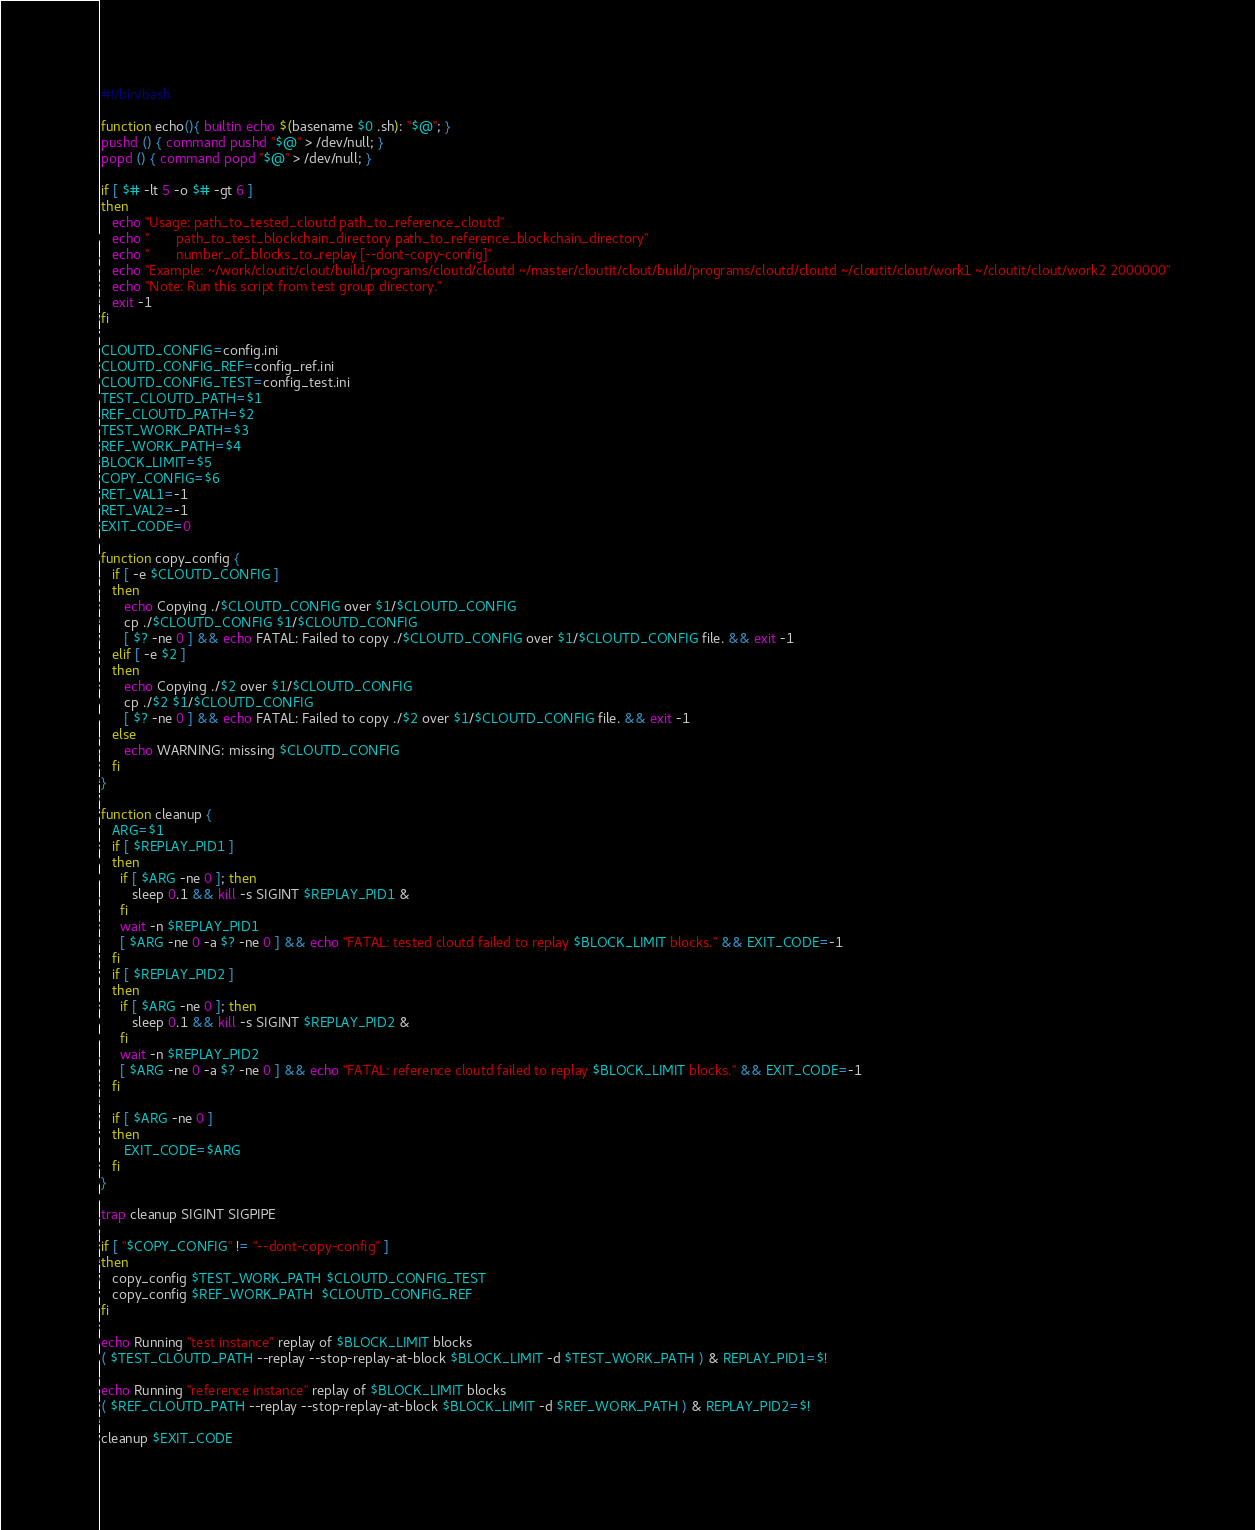Convert code to text. <code><loc_0><loc_0><loc_500><loc_500><_Bash_>#!/bin/bash

function echo(){ builtin echo $(basename $0 .sh): "$@"; }
pushd () { command pushd "$@" > /dev/null; }
popd () { command popd "$@" > /dev/null; }

if [ $# -lt 5 -o $# -gt 6 ]
then
   echo "Usage: path_to_tested_cloutd path_to_reference_cloutd"
   echo "       path_to_test_blockchain_directory path_to_reference_blockchain_directory"
   echo "       number_of_blocks_to_replay [--dont-copy-config]"
   echo "Example: ~/work/cloutit/clout/build/programs/cloutd/cloutd ~/master/cloutit/clout/build/programs/cloutd/cloutd ~/cloutit/clout/work1 ~/cloutit/clout/work2 2000000"
   echo "Note: Run this script from test group directory."
   exit -1
fi

CLOUTD_CONFIG=config.ini
CLOUTD_CONFIG_REF=config_ref.ini
CLOUTD_CONFIG_TEST=config_test.ini
TEST_CLOUTD_PATH=$1
REF_CLOUTD_PATH=$2
TEST_WORK_PATH=$3
REF_WORK_PATH=$4
BLOCK_LIMIT=$5
COPY_CONFIG=$6
RET_VAL1=-1
RET_VAL2=-1
EXIT_CODE=0

function copy_config {
   if [ -e $CLOUTD_CONFIG ]
   then
      echo Copying ./$CLOUTD_CONFIG over $1/$CLOUTD_CONFIG
      cp ./$CLOUTD_CONFIG $1/$CLOUTD_CONFIG
      [ $? -ne 0 ] && echo FATAL: Failed to copy ./$CLOUTD_CONFIG over $1/$CLOUTD_CONFIG file. && exit -1
   elif [ -e $2 ]
   then
      echo Copying ./$2 over $1/$CLOUTD_CONFIG
      cp ./$2 $1/$CLOUTD_CONFIG
      [ $? -ne 0 ] && echo FATAL: Failed to copy ./$2 over $1/$CLOUTD_CONFIG file. && exit -1
   else
      echo WARNING: missing $CLOUTD_CONFIG
   fi
}

function cleanup {
   ARG=$1
   if [ $REPLAY_PID1 ]
   then
     if [ $ARG -ne 0 ]; then
        sleep 0.1 && kill -s SIGINT $REPLAY_PID1 &
     fi
     wait -n $REPLAY_PID1
     [ $ARG -ne 0 -a $? -ne 0 ] && echo "FATAL: tested cloutd failed to replay $BLOCK_LIMIT blocks." && EXIT_CODE=-1
   fi
   if [ $REPLAY_PID2 ]
   then
     if [ $ARG -ne 0 ]; then
        sleep 0.1 && kill -s SIGINT $REPLAY_PID2 &
     fi
     wait -n $REPLAY_PID2
     [ $ARG -ne 0 -a $? -ne 0 ] && echo "FATAL: reference cloutd failed to replay $BLOCK_LIMIT blocks." && EXIT_CODE=-1
   fi

   if [ $ARG -ne 0 ]
   then
      EXIT_CODE=$ARG
   fi
}

trap cleanup SIGINT SIGPIPE

if [ "$COPY_CONFIG" != "--dont-copy-config" ]
then
   copy_config $TEST_WORK_PATH $CLOUTD_CONFIG_TEST
   copy_config $REF_WORK_PATH  $CLOUTD_CONFIG_REF
fi

echo Running "test instance" replay of $BLOCK_LIMIT blocks
( $TEST_CLOUTD_PATH --replay --stop-replay-at-block $BLOCK_LIMIT -d $TEST_WORK_PATH ) & REPLAY_PID1=$!

echo Running "reference instance" replay of $BLOCK_LIMIT blocks
( $REF_CLOUTD_PATH --replay --stop-replay-at-block $BLOCK_LIMIT -d $REF_WORK_PATH ) & REPLAY_PID2=$!

cleanup $EXIT_CODE
</code> 